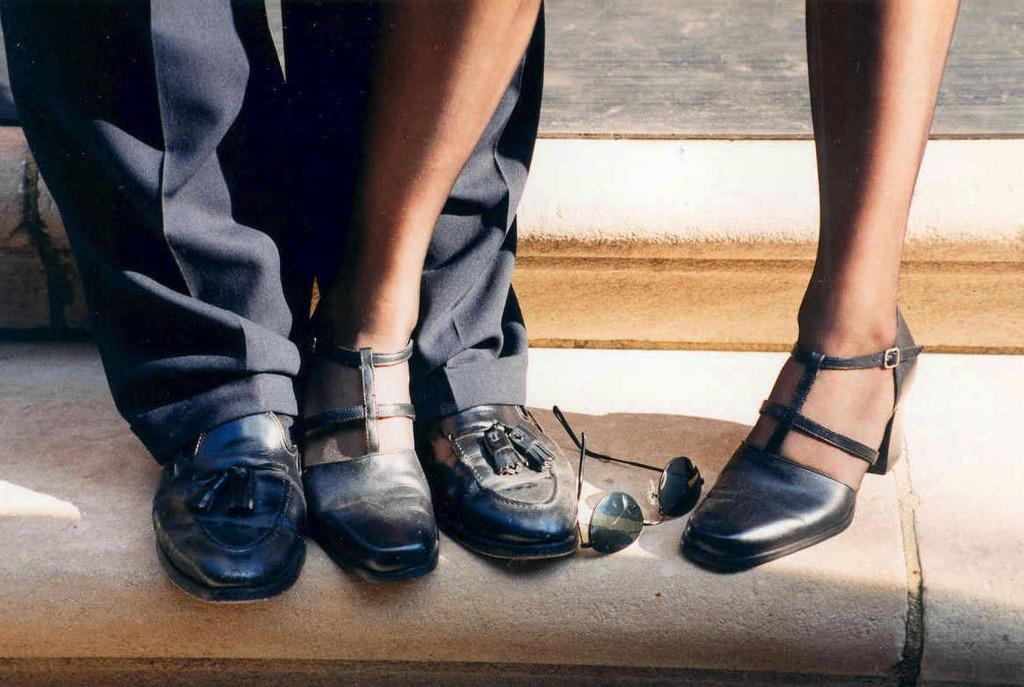What can be seen at the bottom of the image? There are legs of people visible in the image. What are the people wearing on their feet? The people are wearing footwear. What type of protective eyewear is present in the image? Goggles are present in the image. How does the comb affect the people's breath in the image? There is no comb present in the image, so it cannot affect the people's breath. Can you see the people smiling in the image? The provided facts do not mention anything about the people's facial expressions, so we cannot determine if they are smiling or not. 